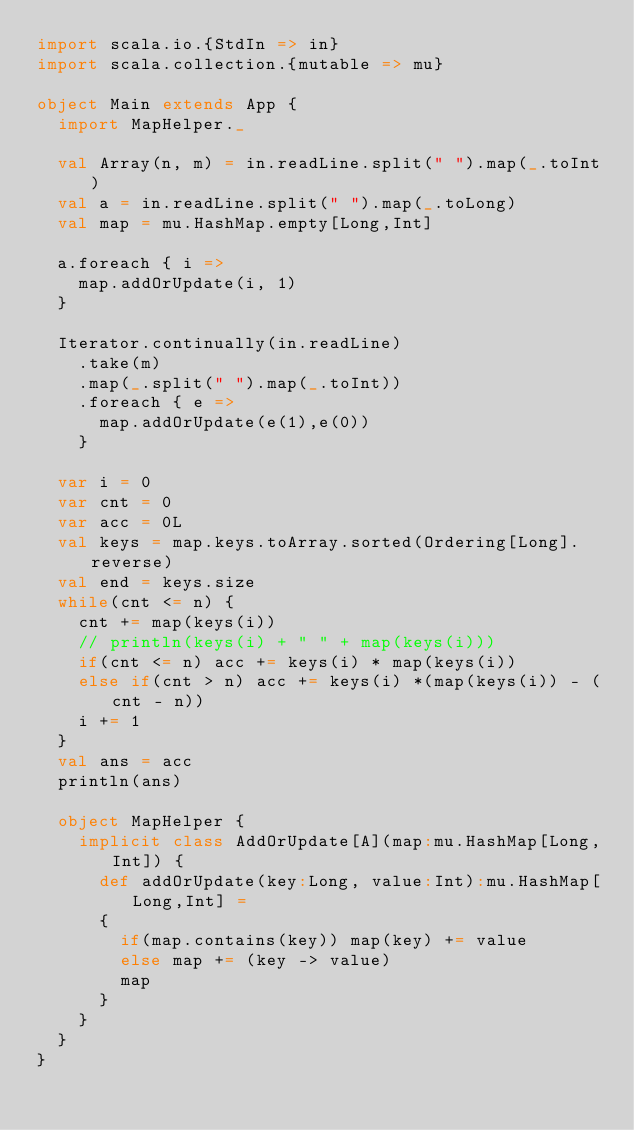Convert code to text. <code><loc_0><loc_0><loc_500><loc_500><_Scala_>import scala.io.{StdIn => in}
import scala.collection.{mutable => mu}

object Main extends App {
  import MapHelper._

  val Array(n, m) = in.readLine.split(" ").map(_.toInt)
  val a = in.readLine.split(" ").map(_.toLong)
  val map = mu.HashMap.empty[Long,Int]

  a.foreach { i =>
    map.addOrUpdate(i, 1)
  }

  Iterator.continually(in.readLine)
    .take(m)
    .map(_.split(" ").map(_.toInt))
    .foreach { e =>
      map.addOrUpdate(e(1),e(0))
    }
  
  var i = 0
  var cnt = 0
  var acc = 0L
  val keys = map.keys.toArray.sorted(Ordering[Long].reverse)
  val end = keys.size
  while(cnt <= n) {
    cnt += map(keys(i))
    // println(keys(i) + " " + map(keys(i)))
    if(cnt <= n) acc += keys(i) * map(keys(i))
    else if(cnt > n) acc += keys(i) *(map(keys(i)) - (cnt - n))
    i += 1
  }
  val ans = acc
  println(ans)

  object MapHelper {
    implicit class AddOrUpdate[A](map:mu.HashMap[Long,Int]) {
      def addOrUpdate(key:Long, value:Int):mu.HashMap[Long,Int] =
      {
        if(map.contains(key)) map(key) += value
        else map += (key -> value)
        map
      }
    }
  }
}</code> 